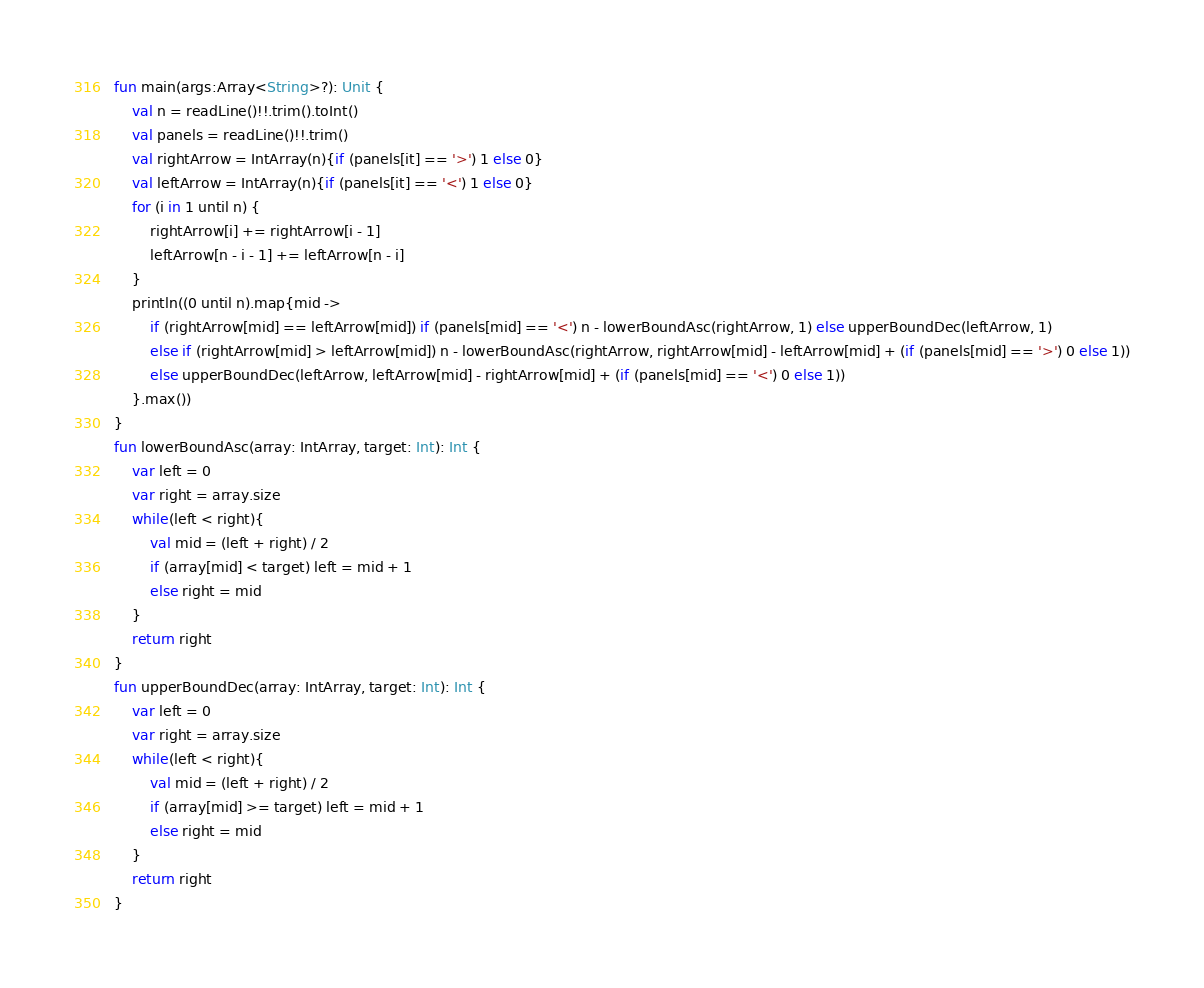<code> <loc_0><loc_0><loc_500><loc_500><_Kotlin_>fun main(args:Array<String>?): Unit {
    val n = readLine()!!.trim().toInt()
    val panels = readLine()!!.trim()
    val rightArrow = IntArray(n){if (panels[it] == '>') 1 else 0}
    val leftArrow = IntArray(n){if (panels[it] == '<') 1 else 0}
    for (i in 1 until n) {
        rightArrow[i] += rightArrow[i - 1]
        leftArrow[n - i - 1] += leftArrow[n - i]
    }
    println((0 until n).map{mid ->
        if (rightArrow[mid] == leftArrow[mid]) if (panels[mid] == '<') n - lowerBoundAsc(rightArrow, 1) else upperBoundDec(leftArrow, 1)
        else if (rightArrow[mid] > leftArrow[mid]) n - lowerBoundAsc(rightArrow, rightArrow[mid] - leftArrow[mid] + (if (panels[mid] == '>') 0 else 1))
        else upperBoundDec(leftArrow, leftArrow[mid] - rightArrow[mid] + (if (panels[mid] == '<') 0 else 1))
    }.max())
}
fun lowerBoundAsc(array: IntArray, target: Int): Int {
    var left = 0
    var right = array.size
    while(left < right){
        val mid = (left + right) / 2
        if (array[mid] < target) left = mid + 1
        else right = mid
    }
    return right
}
fun upperBoundDec(array: IntArray, target: Int): Int {
    var left = 0
    var right = array.size
    while(left < right){
        val mid = (left + right) / 2
        if (array[mid] >= target) left = mid + 1
        else right = mid
    }
    return right
}
</code> 